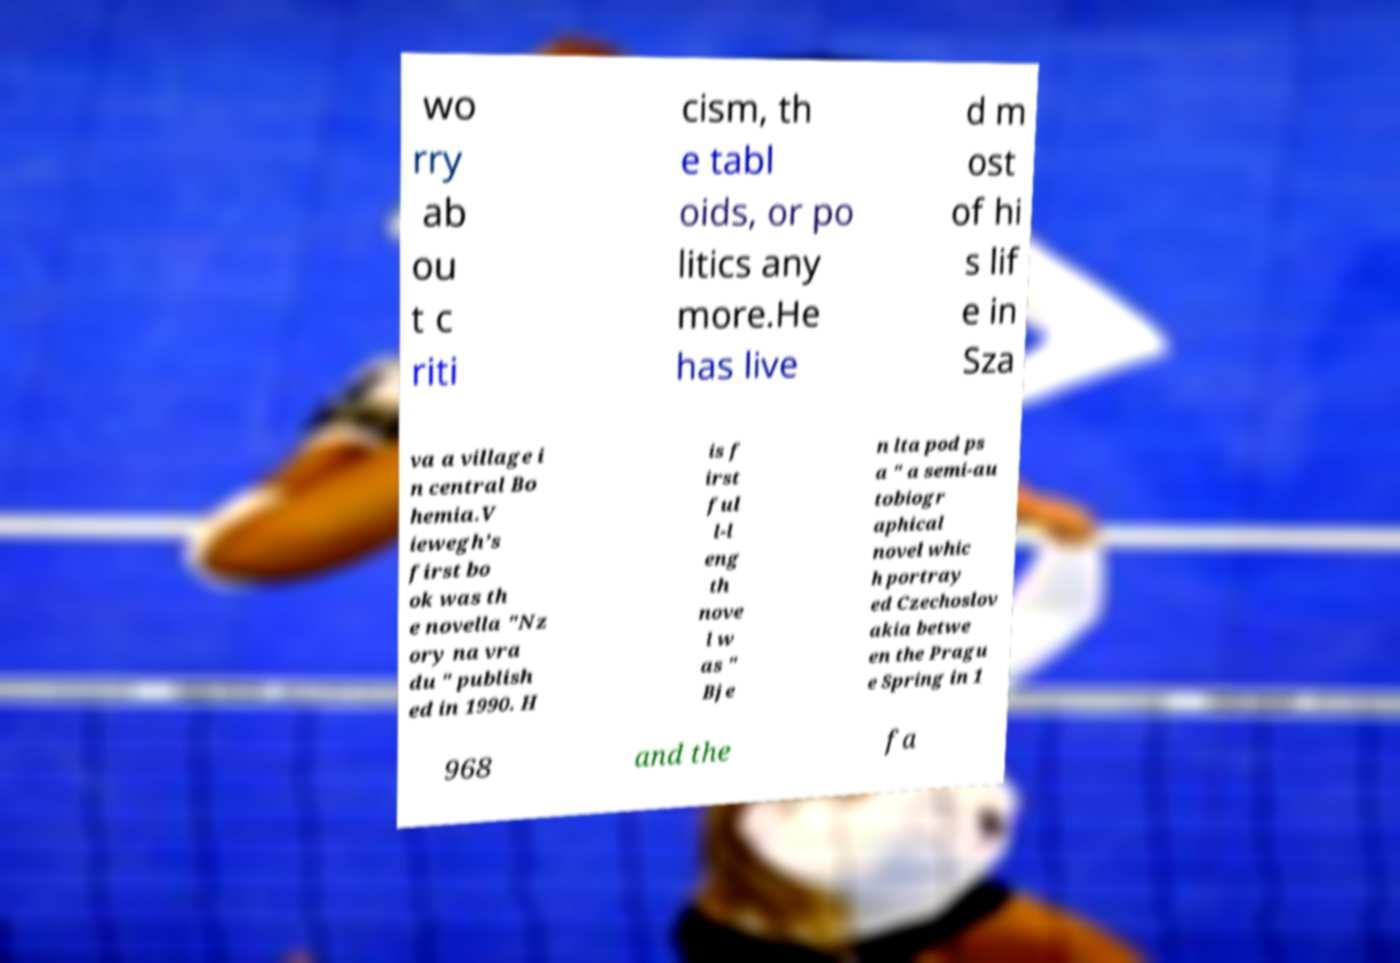Can you accurately transcribe the text from the provided image for me? wo rry ab ou t c riti cism, th e tabl oids, or po litics any more.He has live d m ost of hi s lif e in Sza va a village i n central Bo hemia.V iewegh’s first bo ok was th e novella "Nz ory na vra du " publish ed in 1990. H is f irst ful l-l eng th nove l w as " Bje n lta pod ps a " a semi-au tobiogr aphical novel whic h portray ed Czechoslov akia betwe en the Pragu e Spring in 1 968 and the fa 